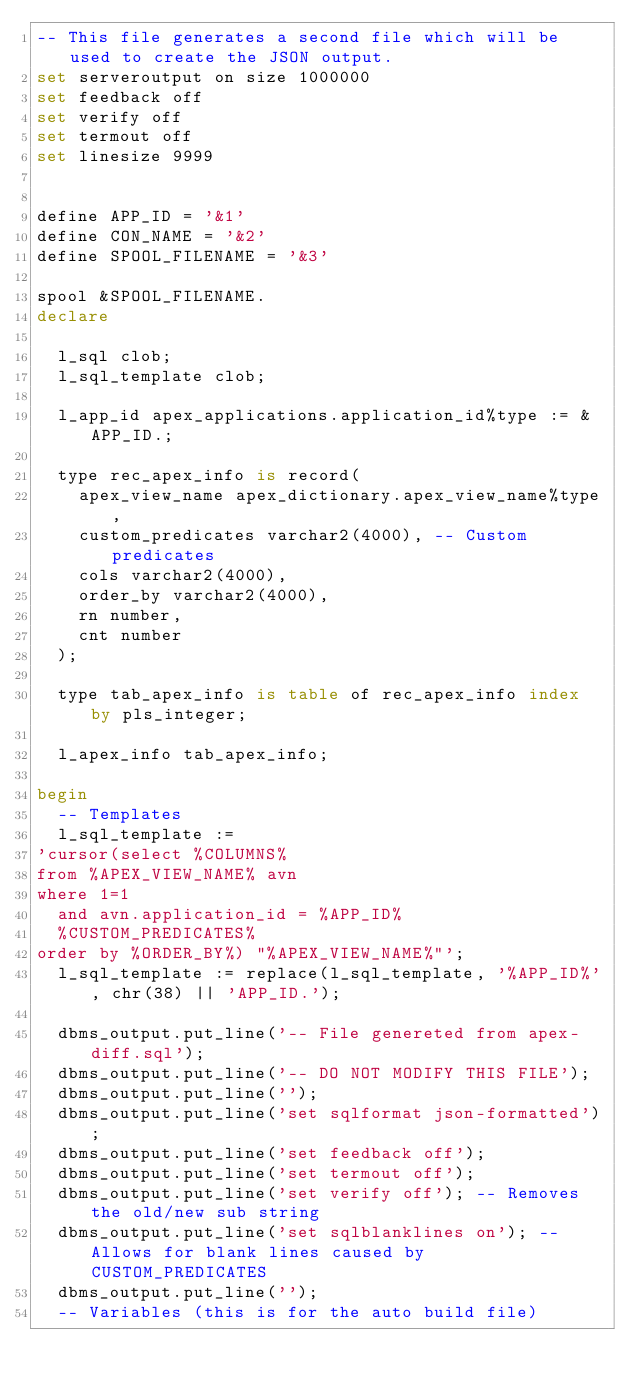<code> <loc_0><loc_0><loc_500><loc_500><_SQL_>-- This file generates a second file which will be used to create the JSON output.
set serveroutput on size 1000000
set feedback off
set verify off
set termout off
set linesize 9999


define APP_ID = '&1'
define CON_NAME = '&2'
define SPOOL_FILENAME = '&3'

spool &SPOOL_FILENAME.
declare

  l_sql clob;
  l_sql_template clob;

  l_app_id apex_applications.application_id%type := &APP_ID.;

  type rec_apex_info is record(
    apex_view_name apex_dictionary.apex_view_name%type,
    custom_predicates varchar2(4000), -- Custom predicates
    cols varchar2(4000),
    order_by varchar2(4000),
    rn number,
    cnt number
  );

  type tab_apex_info is table of rec_apex_info index by pls_integer;

  l_apex_info tab_apex_info;

begin
  -- Templates
  l_sql_template :=
'cursor(select %COLUMNS%
from %APEX_VIEW_NAME% avn
where 1=1
  and avn.application_id = %APP_ID%
  %CUSTOM_PREDICATES%
order by %ORDER_BY%) "%APEX_VIEW_NAME%"';
  l_sql_template := replace(l_sql_template, '%APP_ID%', chr(38) || 'APP_ID.');

  dbms_output.put_line('-- File genereted from apex-diff.sql');
  dbms_output.put_line('-- DO NOT MODIFY THIS FILE');
  dbms_output.put_line('');
  dbms_output.put_line('set sqlformat json-formatted');
  dbms_output.put_line('set feedback off');
  dbms_output.put_line('set termout off');
  dbms_output.put_line('set verify off'); -- Removes the old/new sub string
  dbms_output.put_line('set sqlblanklines on'); -- Allows for blank lines caused by CUSTOM_PREDICATES
  dbms_output.put_line('');
  -- Variables (this is for the auto build file)</code> 